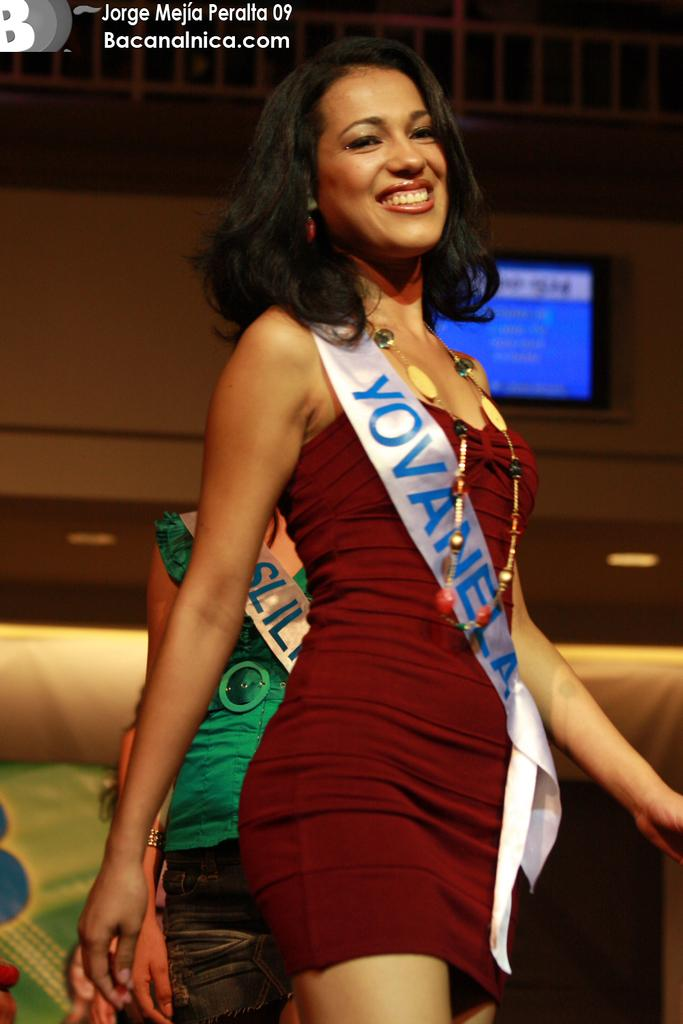<image>
Share a concise interpretation of the image provided. A woman in red wears a white sash that says YOVANELA on it 